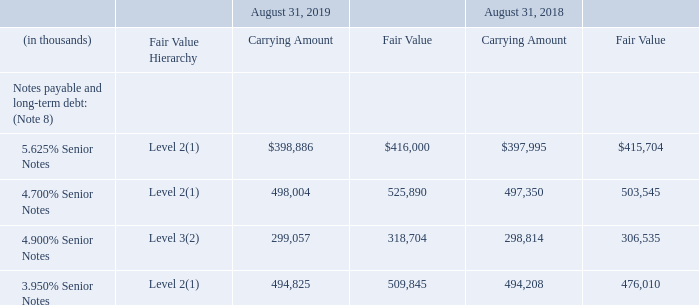Fair Value of Financial Instruments
The carrying amounts of cash and cash equivalents, trade accounts receivable, prepaid expenses and other current assets, accounts payable and accrued expenses approximate fair value because of the short-term nature of these financial instruments. The carrying amounts of borrowings under credit facilities and under loans approximates fair value as interest rates on these instruments approximates current market rates.
Notes payable and long-term debt is carried at amortized cost; however, the Company estimates the fair value of notes payable and long-term debt for disclosure purposes. The following table presents the carrying amounts and fair values of the Company’s notes payable and long-term debt, by hierarchy level as of the periods indicated:
(1) The fair value estimates are based upon observable market data.
(2) This fair value estimate is based on the Company’s indicative borrowing cost derived from discounted cash flows.
Refer to Note 9 – “Postretirement and Other Employee Benefits” for disclosure surrounding the fair value of the Company’s pension plan assets.
What were the Level 3 fair value estimates based on? The company’s indicative borrowing cost derived from discounted cash flows. What were the Level 2 fair value estimates based on? Observable market data. What was the carrying amount in the 5.625% Senior Notes in 2019?
Answer scale should be: thousand. $398,886. What was the change in the fair value for the 4.700% Senior Notes between 2018 and 2019?
Answer scale should be: thousand. 525,890-503,545
Answer: 22345. What was the change in the fair value for the 3.950% Senior Notes between 2018 and 2019?
Answer scale should be: thousand. 509,845-476,010
Answer: 33835. What was the percentage change in the carrying amount for the 4.900% Senior Notes between 2018 and 2019?
Answer scale should be: percent. (299,057-298,814)/298,814
Answer: 0.08. 